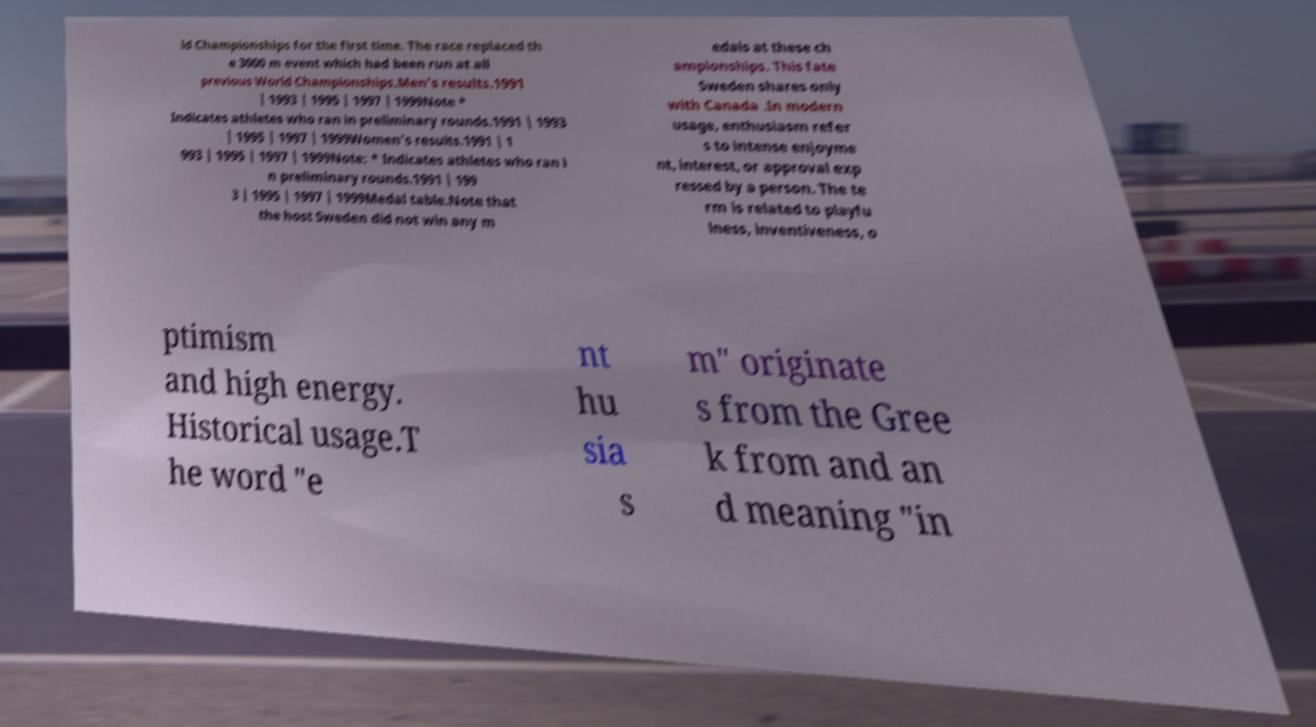Please identify and transcribe the text found in this image. ld Championships for the first time. The race replaced th e 3000 m event which had been run at all previous World Championships.Men's results.1991 | 1993 | 1995 | 1997 | 1999Note * Indicates athletes who ran in preliminary rounds.1991 | 1993 | 1995 | 1997 | 1999Women's results.1991 | 1 993 | 1995 | 1997 | 1999Note: * Indicates athletes who ran i n preliminary rounds.1991 | 199 3 | 1995 | 1997 | 1999Medal table.Note that the host Sweden did not win any m edals at these ch ampionships. This fate Sweden shares only with Canada .In modern usage, enthusiasm refer s to intense enjoyme nt, interest, or approval exp ressed by a person. The te rm is related to playfu lness, inventiveness, o ptimism and high energy. Historical usage.T he word "e nt hu sia s m" originate s from the Gree k from and an d meaning "in 